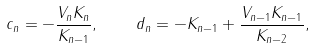Convert formula to latex. <formula><loc_0><loc_0><loc_500><loc_500>c _ { n } = - \frac { V _ { n } K _ { n } } { K _ { n - 1 } } , \quad d _ { n } = - K _ { n - 1 } + \frac { V _ { n - 1 } K _ { n - 1 } } { K _ { n - 2 } } ,</formula> 